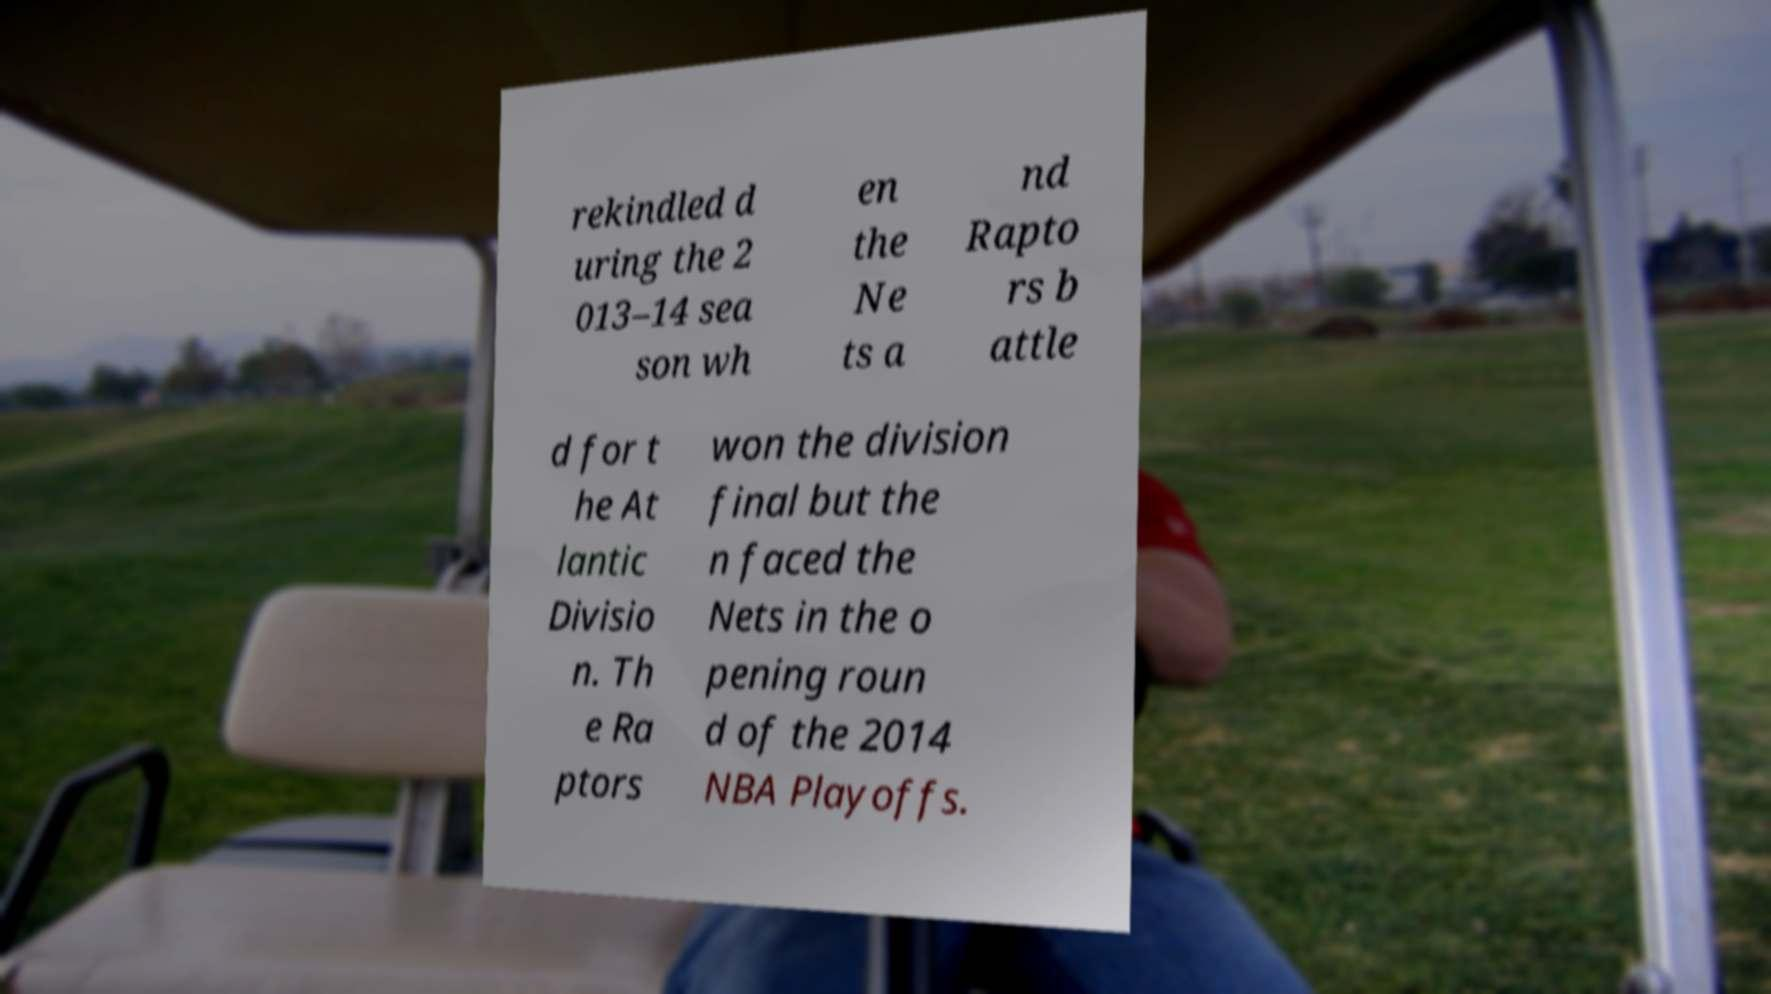What messages or text are displayed in this image? I need them in a readable, typed format. rekindled d uring the 2 013–14 sea son wh en the Ne ts a nd Rapto rs b attle d for t he At lantic Divisio n. Th e Ra ptors won the division final but the n faced the Nets in the o pening roun d of the 2014 NBA Playoffs. 